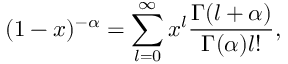<formula> <loc_0><loc_0><loc_500><loc_500>( 1 - x ) ^ { - \alpha } = \sum _ { l = 0 } ^ { \infty } x ^ { l } \frac { \Gamma ( l + \alpha ) } { \Gamma ( \alpha ) l ! } ,</formula> 